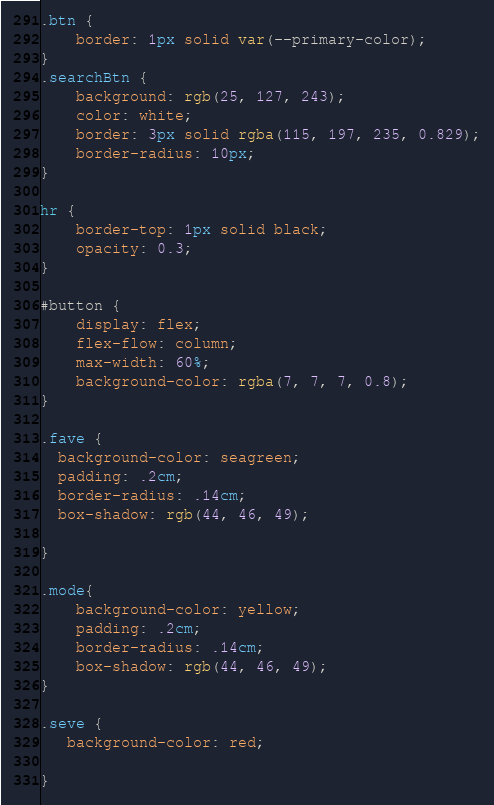Convert code to text. <code><loc_0><loc_0><loc_500><loc_500><_CSS_>.btn {
    border: 1px solid var(--primary-color);
}
.searchBtn {
    background: rgb(25, 127, 243);
    color: white;
    border: 3px solid rgba(115, 197, 235, 0.829);
    border-radius: 10px;
}

hr {
    border-top: 1px solid black;
    opacity: 0.3;
}

#button {
    display: flex;
    flex-flow: column;
    max-width: 60%;
    background-color: rgba(7, 7, 7, 0.8);
}

.fave {
  background-color: seagreen;
  padding: .2cm;
  border-radius: .14cm;
  box-shadow: rgb(44, 46, 49);
  
}

.mode{ 
    background-color: yellow;
    padding: .2cm;
    border-radius: .14cm;
    box-shadow: rgb(44, 46, 49);
}

.seve {
   background-color: red;
   
}</code> 